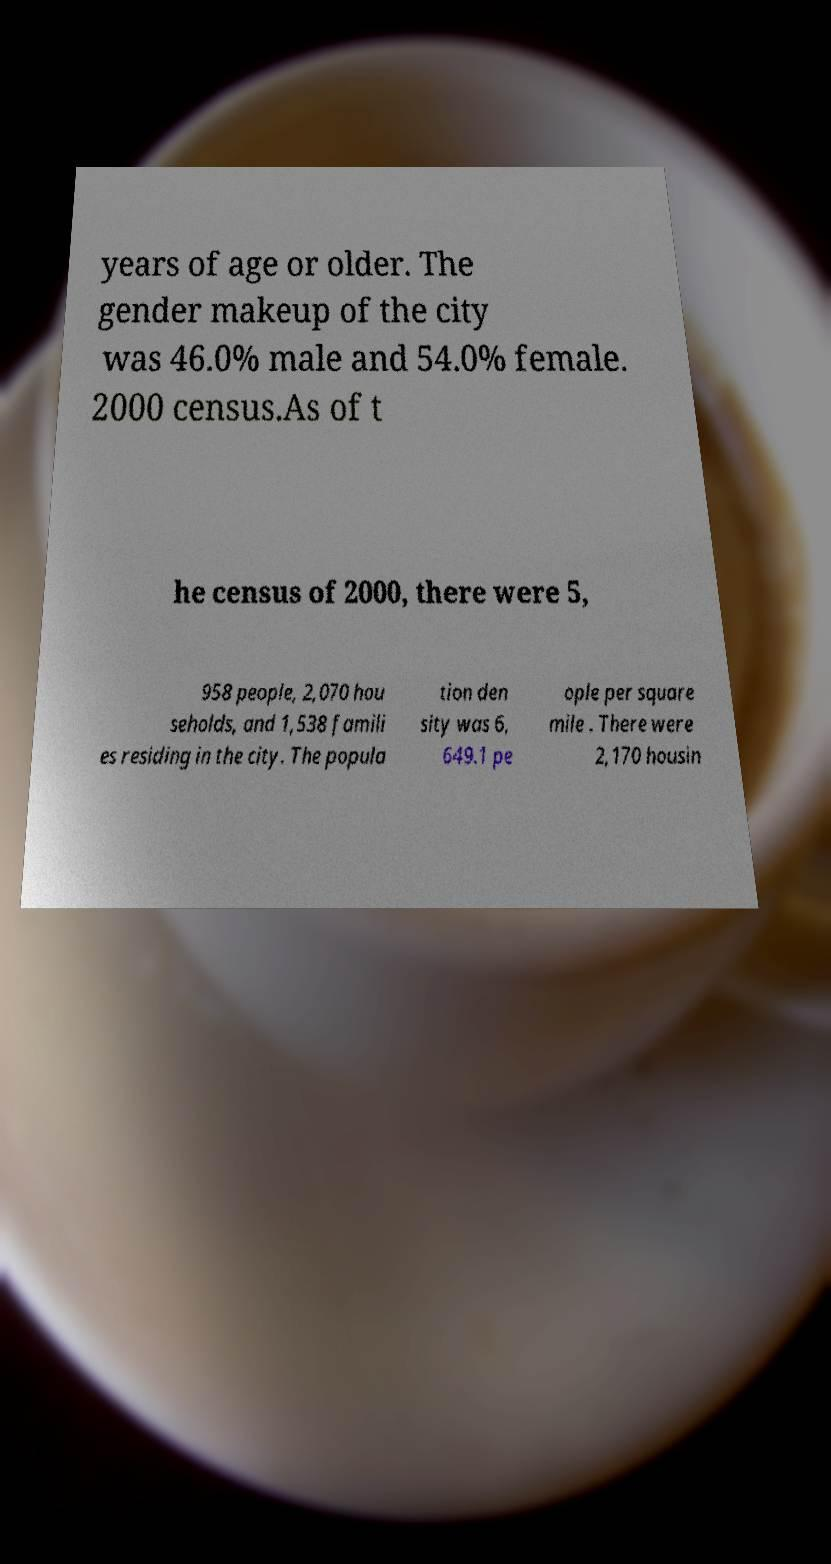I need the written content from this picture converted into text. Can you do that? years of age or older. The gender makeup of the city was 46.0% male and 54.0% female. 2000 census.As of t he census of 2000, there were 5, 958 people, 2,070 hou seholds, and 1,538 famili es residing in the city. The popula tion den sity was 6, 649.1 pe ople per square mile . There were 2,170 housin 